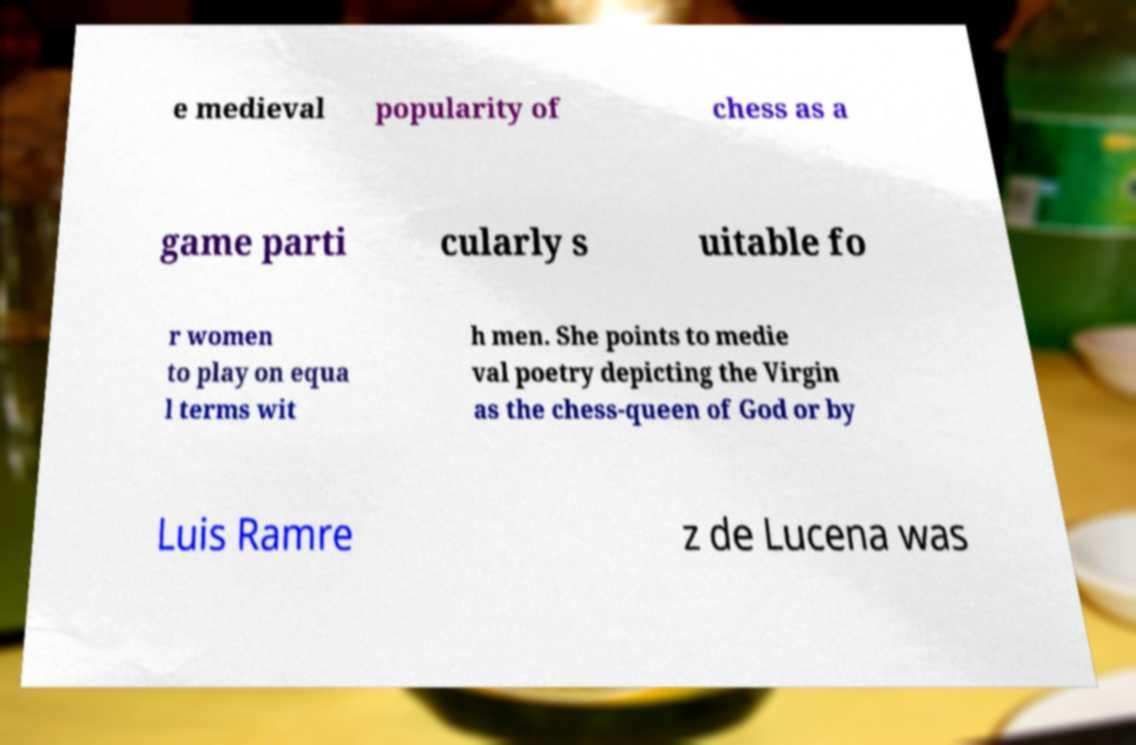I need the written content from this picture converted into text. Can you do that? e medieval popularity of chess as a game parti cularly s uitable fo r women to play on equa l terms wit h men. She points to medie val poetry depicting the Virgin as the chess-queen of God or by Luis Ramre z de Lucena was 